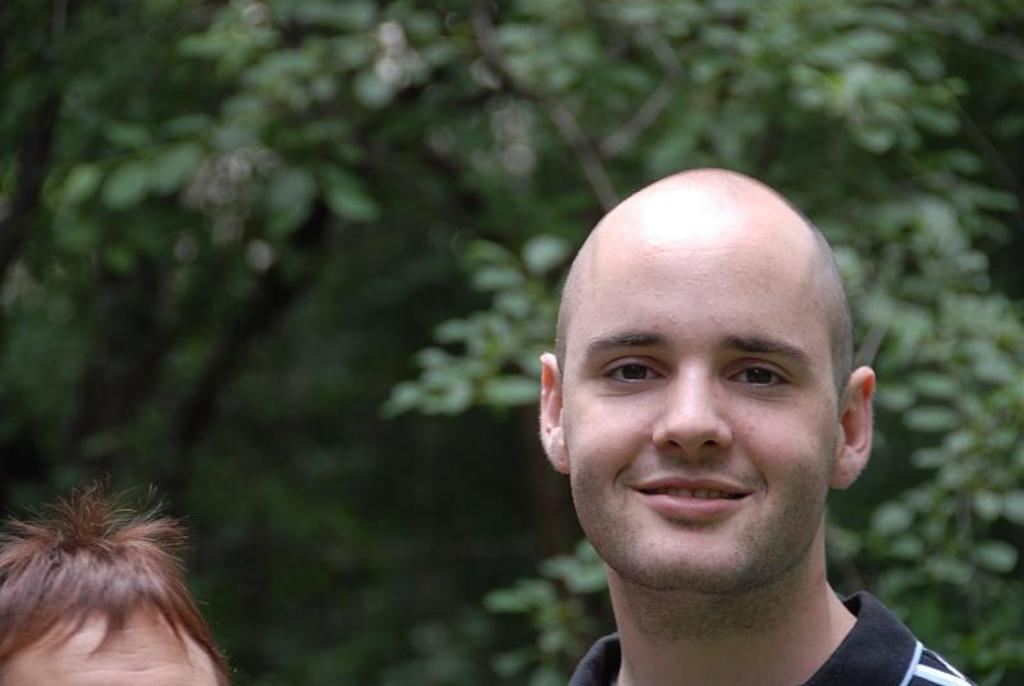How many people are present in the image? There are two people in the image. What can be seen in the background of the image? There are trees in the background of the image. How would you describe the appearance of the background? The background appears blurry. What type of tin is being used by the owner in the image? There is no tin or owner present in the image. How many icicles are hanging from the trees in the image? There are no icicles visible in the image, as it does not depict a winter scene. 